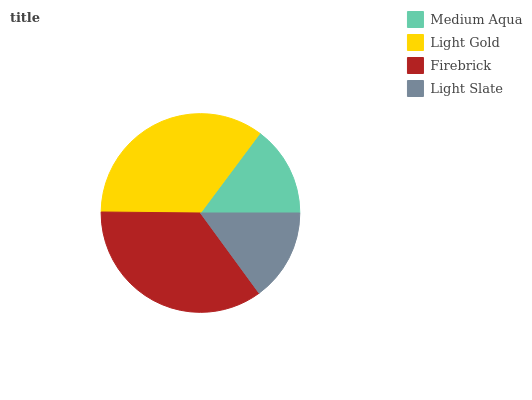Is Medium Aqua the minimum?
Answer yes or no. Yes. Is Firebrick the maximum?
Answer yes or no. Yes. Is Light Gold the minimum?
Answer yes or no. No. Is Light Gold the maximum?
Answer yes or no. No. Is Light Gold greater than Medium Aqua?
Answer yes or no. Yes. Is Medium Aqua less than Light Gold?
Answer yes or no. Yes. Is Medium Aqua greater than Light Gold?
Answer yes or no. No. Is Light Gold less than Medium Aqua?
Answer yes or no. No. Is Light Gold the high median?
Answer yes or no. Yes. Is Light Slate the low median?
Answer yes or no. Yes. Is Light Slate the high median?
Answer yes or no. No. Is Medium Aqua the low median?
Answer yes or no. No. 